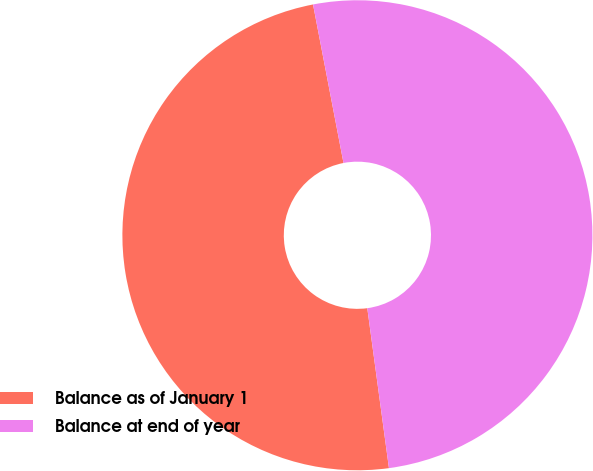Convert chart to OTSL. <chart><loc_0><loc_0><loc_500><loc_500><pie_chart><fcel>Balance as of January 1<fcel>Balance at end of year<nl><fcel>49.12%<fcel>50.88%<nl></chart> 